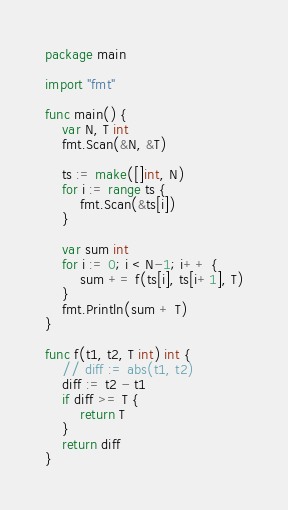Convert code to text. <code><loc_0><loc_0><loc_500><loc_500><_Go_>package main

import "fmt"

func main() {
	var N, T int
	fmt.Scan(&N, &T)

	ts := make([]int, N)
	for i := range ts {
		fmt.Scan(&ts[i])
	}

	var sum int
	for i := 0; i < N-1; i++ {
		sum += f(ts[i], ts[i+1], T)
	}
	fmt.Println(sum + T)
}

func f(t1, t2, T int) int {
	// diff := abs(t1, t2)
	diff := t2 - t1
	if diff >= T {
		return T
	}
	return diff
}</code> 